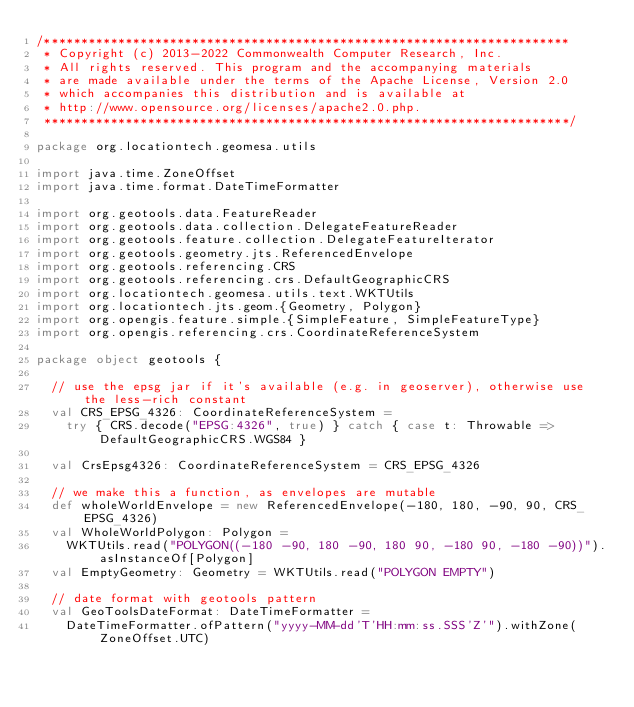Convert code to text. <code><loc_0><loc_0><loc_500><loc_500><_Scala_>/***********************************************************************
 * Copyright (c) 2013-2022 Commonwealth Computer Research, Inc.
 * All rights reserved. This program and the accompanying materials
 * are made available under the terms of the Apache License, Version 2.0
 * which accompanies this distribution and is available at
 * http://www.opensource.org/licenses/apache2.0.php.
 ***********************************************************************/

package org.locationtech.geomesa.utils

import java.time.ZoneOffset
import java.time.format.DateTimeFormatter

import org.geotools.data.FeatureReader
import org.geotools.data.collection.DelegateFeatureReader
import org.geotools.feature.collection.DelegateFeatureIterator
import org.geotools.geometry.jts.ReferencedEnvelope
import org.geotools.referencing.CRS
import org.geotools.referencing.crs.DefaultGeographicCRS
import org.locationtech.geomesa.utils.text.WKTUtils
import org.locationtech.jts.geom.{Geometry, Polygon}
import org.opengis.feature.simple.{SimpleFeature, SimpleFeatureType}
import org.opengis.referencing.crs.CoordinateReferenceSystem

package object geotools {

  // use the epsg jar if it's available (e.g. in geoserver), otherwise use the less-rich constant
  val CRS_EPSG_4326: CoordinateReferenceSystem =
    try { CRS.decode("EPSG:4326", true) } catch { case t: Throwable => DefaultGeographicCRS.WGS84 }

  val CrsEpsg4326: CoordinateReferenceSystem = CRS_EPSG_4326

  // we make this a function, as envelopes are mutable
  def wholeWorldEnvelope = new ReferencedEnvelope(-180, 180, -90, 90, CRS_EPSG_4326)
  val WholeWorldPolygon: Polygon =
    WKTUtils.read("POLYGON((-180 -90, 180 -90, 180 90, -180 90, -180 -90))").asInstanceOf[Polygon]
  val EmptyGeometry: Geometry = WKTUtils.read("POLYGON EMPTY")

  // date format with geotools pattern
  val GeoToolsDateFormat: DateTimeFormatter =
    DateTimeFormatter.ofPattern("yyyy-MM-dd'T'HH:mm:ss.SSS'Z'").withZone(ZoneOffset.UTC)
</code> 